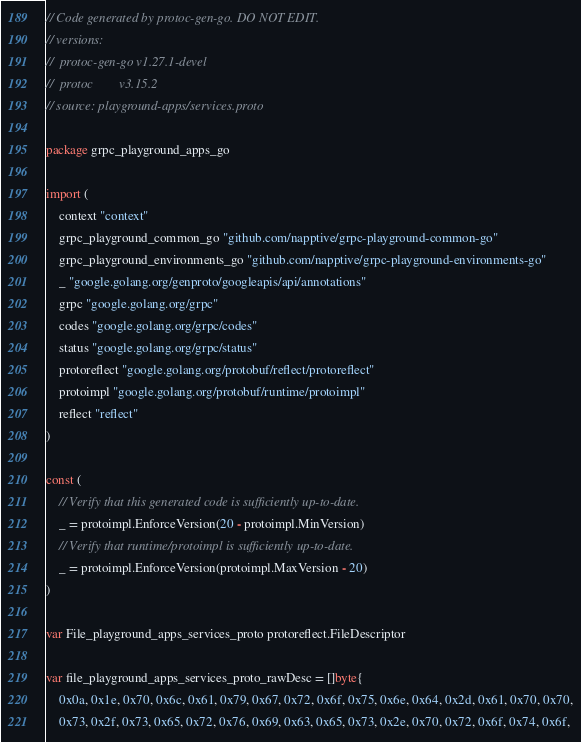Convert code to text. <code><loc_0><loc_0><loc_500><loc_500><_Go_>// Code generated by protoc-gen-go. DO NOT EDIT.
// versions:
// 	protoc-gen-go v1.27.1-devel
// 	protoc        v3.15.2
// source: playground-apps/services.proto

package grpc_playground_apps_go

import (
	context "context"
	grpc_playground_common_go "github.com/napptive/grpc-playground-common-go"
	grpc_playground_environments_go "github.com/napptive/grpc-playground-environments-go"
	_ "google.golang.org/genproto/googleapis/api/annotations"
	grpc "google.golang.org/grpc"
	codes "google.golang.org/grpc/codes"
	status "google.golang.org/grpc/status"
	protoreflect "google.golang.org/protobuf/reflect/protoreflect"
	protoimpl "google.golang.org/protobuf/runtime/protoimpl"
	reflect "reflect"
)

const (
	// Verify that this generated code is sufficiently up-to-date.
	_ = protoimpl.EnforceVersion(20 - protoimpl.MinVersion)
	// Verify that runtime/protoimpl is sufficiently up-to-date.
	_ = protoimpl.EnforceVersion(protoimpl.MaxVersion - 20)
)

var File_playground_apps_services_proto protoreflect.FileDescriptor

var file_playground_apps_services_proto_rawDesc = []byte{
	0x0a, 0x1e, 0x70, 0x6c, 0x61, 0x79, 0x67, 0x72, 0x6f, 0x75, 0x6e, 0x64, 0x2d, 0x61, 0x70, 0x70,
	0x73, 0x2f, 0x73, 0x65, 0x72, 0x76, 0x69, 0x63, 0x65, 0x73, 0x2e, 0x70, 0x72, 0x6f, 0x74, 0x6f,</code> 